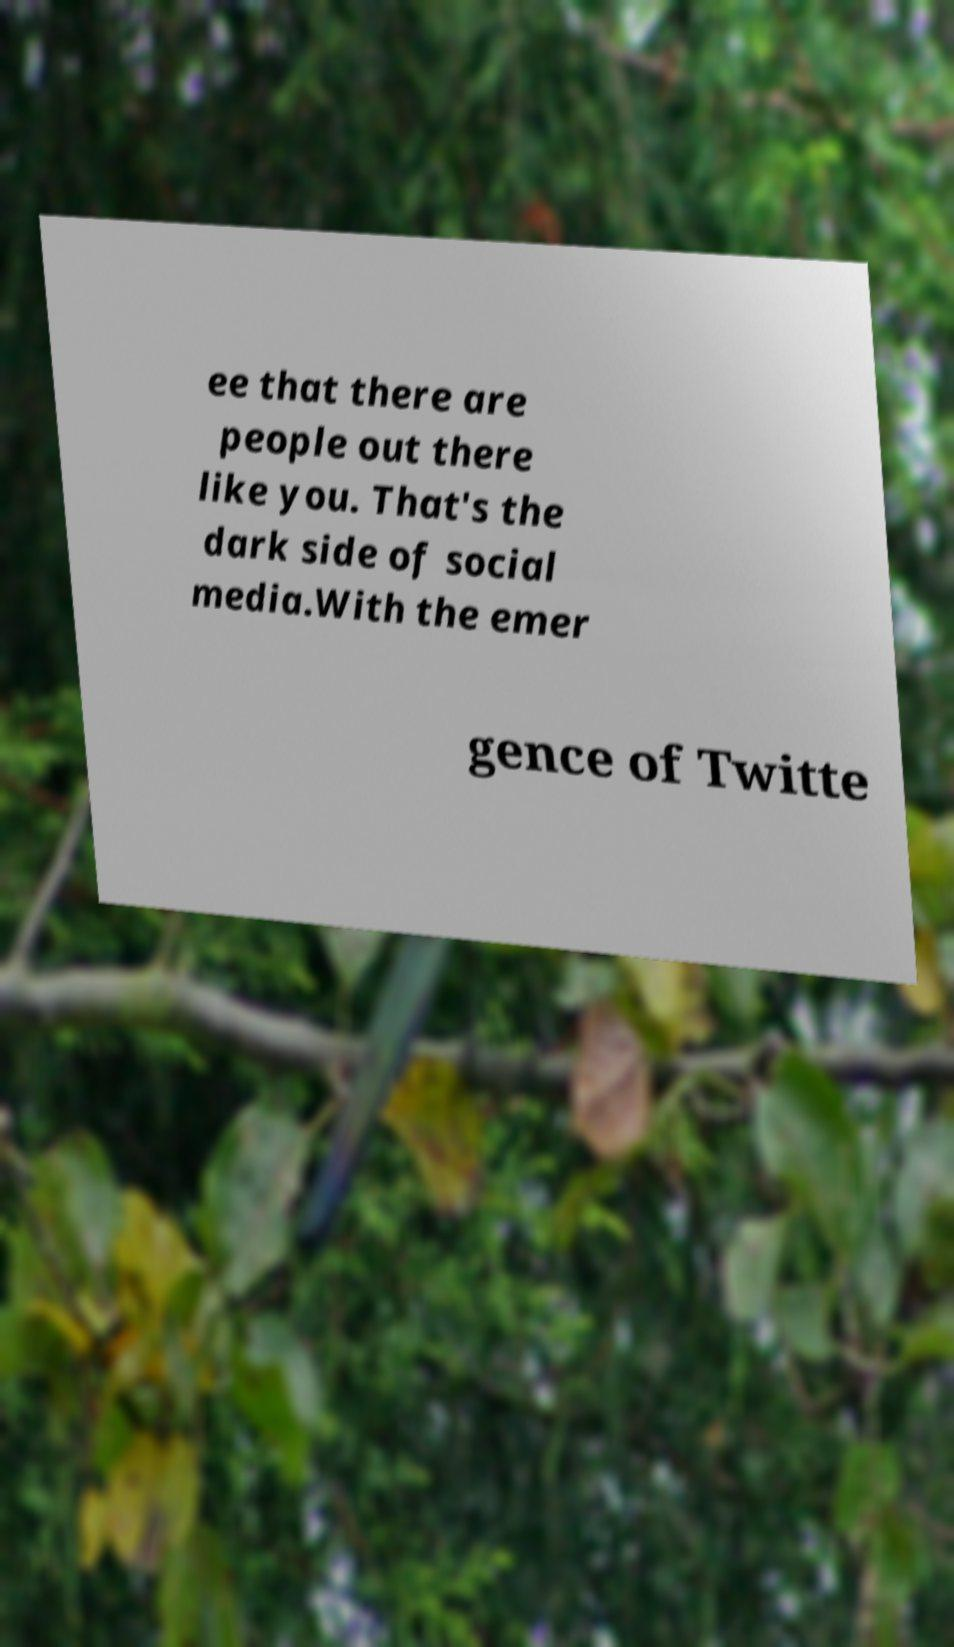I need the written content from this picture converted into text. Can you do that? ee that there are people out there like you. That's the dark side of social media.With the emer gence of Twitte 